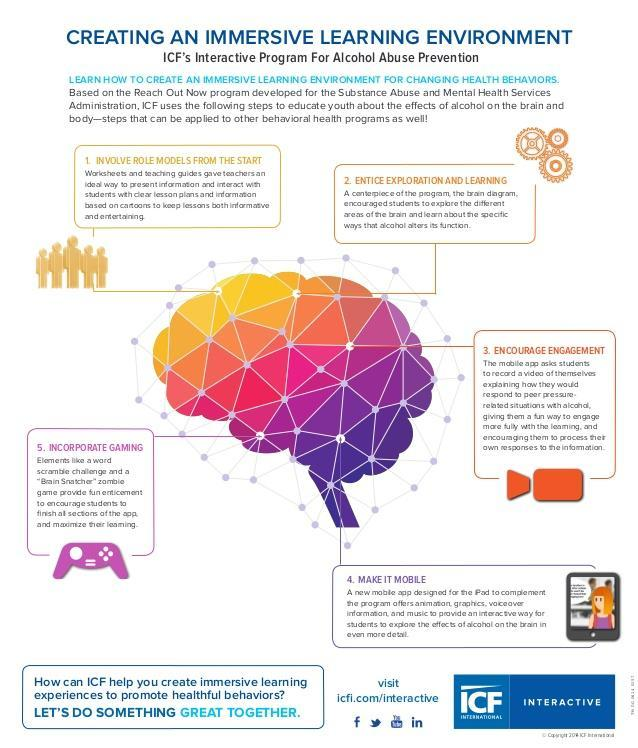Which color used to represent "Incorporate Gaming"-orange, yellow, violet, pink?
Answer the question with a short phrase. violet Which color used to represent "Encourage Engagement"-violet, yellow, orange, pink? orange 